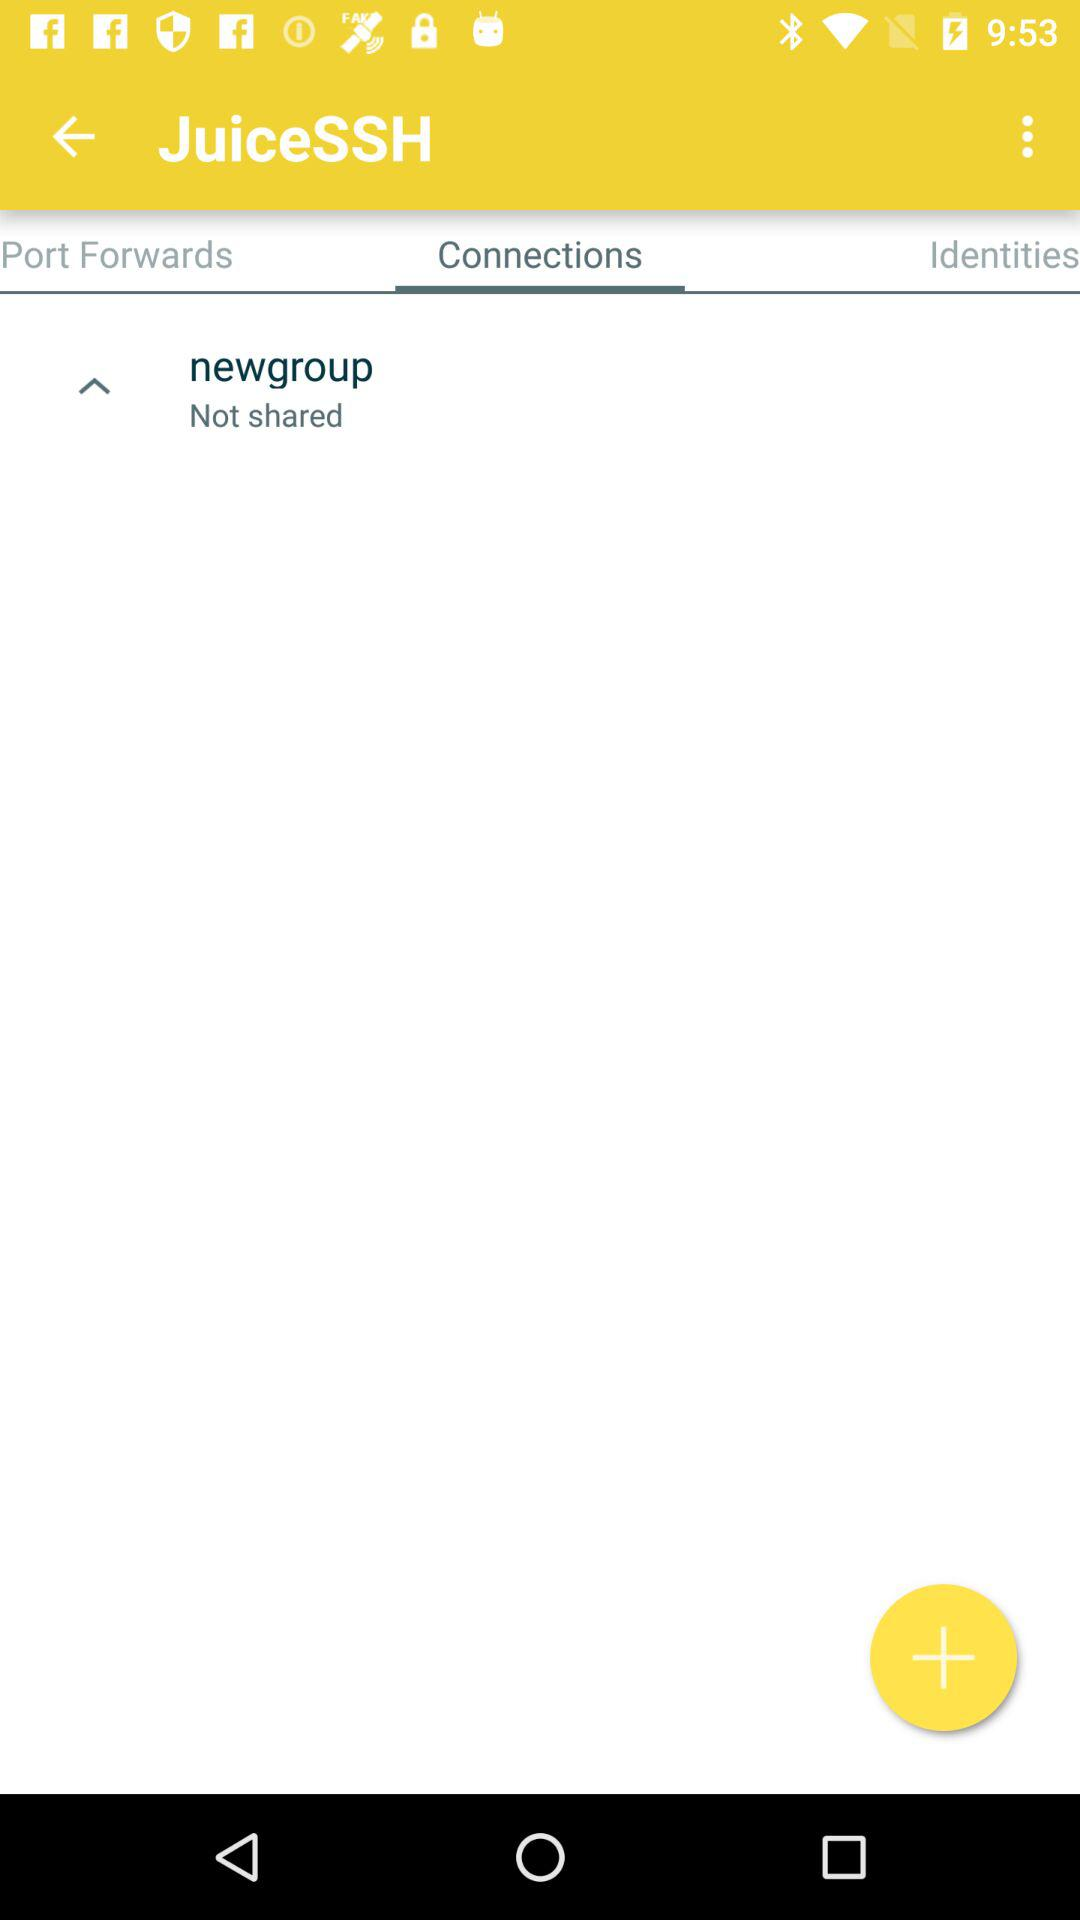How many items are in "Port Forwards"?
When the provided information is insufficient, respond with <no answer>. <no answer> 